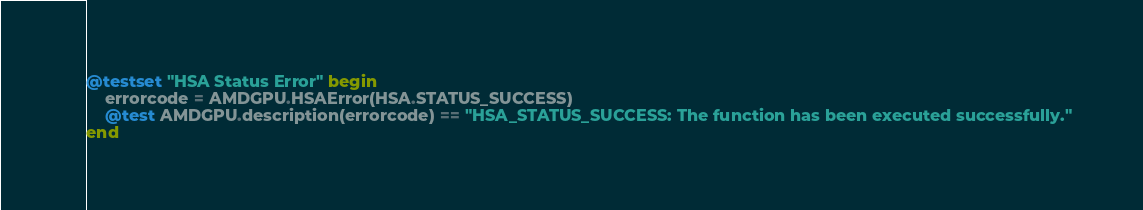<code> <loc_0><loc_0><loc_500><loc_500><_Julia_>@testset "HSA Status Error" begin
    errorcode = AMDGPU.HSAError(HSA.STATUS_SUCCESS)
    @test AMDGPU.description(errorcode) == "HSA_STATUS_SUCCESS: The function has been executed successfully."
end
</code> 